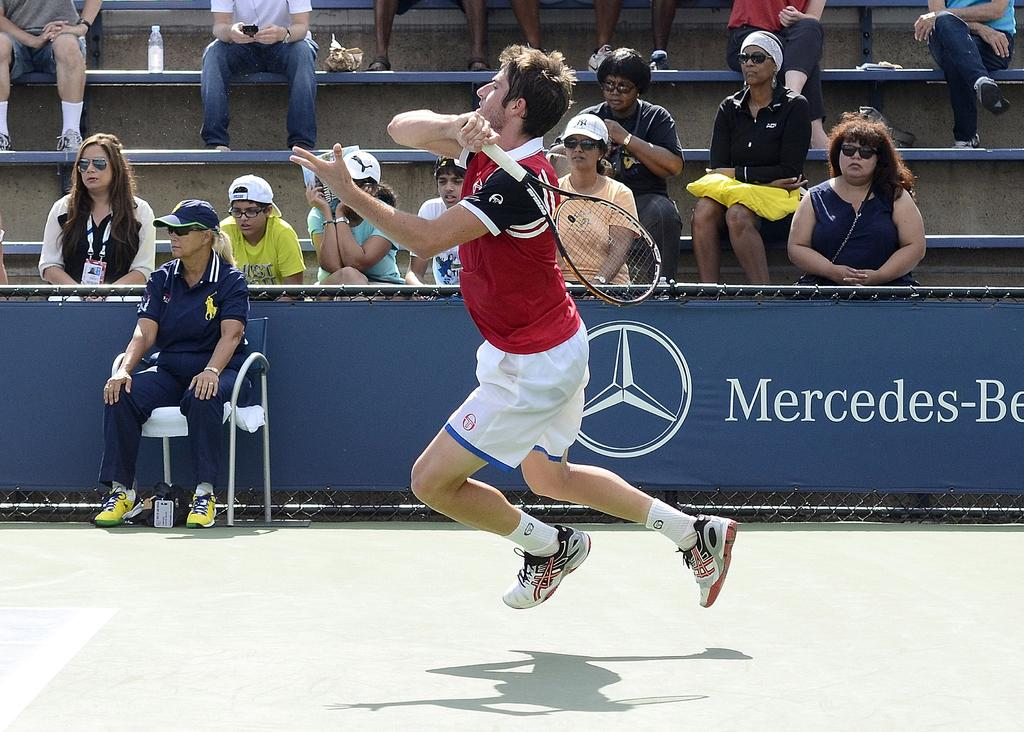What is the person in the image doing? The person is playing tennis. What is the person wearing while playing tennis? The person is wearing a maroon t-shirt and white shorts. What can be seen in the background of the image? There are people sitting on steps behind a fence in the background of the image. What is the main setting of the image? The tennis field is visible in the image. Is the person in the image sleeping on the tennis field? No, the person in the image is playing tennis, not sleeping. Can you see any dust particles in the image? There is no mention of dust particles in the provided facts, so it cannot be determined if they are present in the image. 